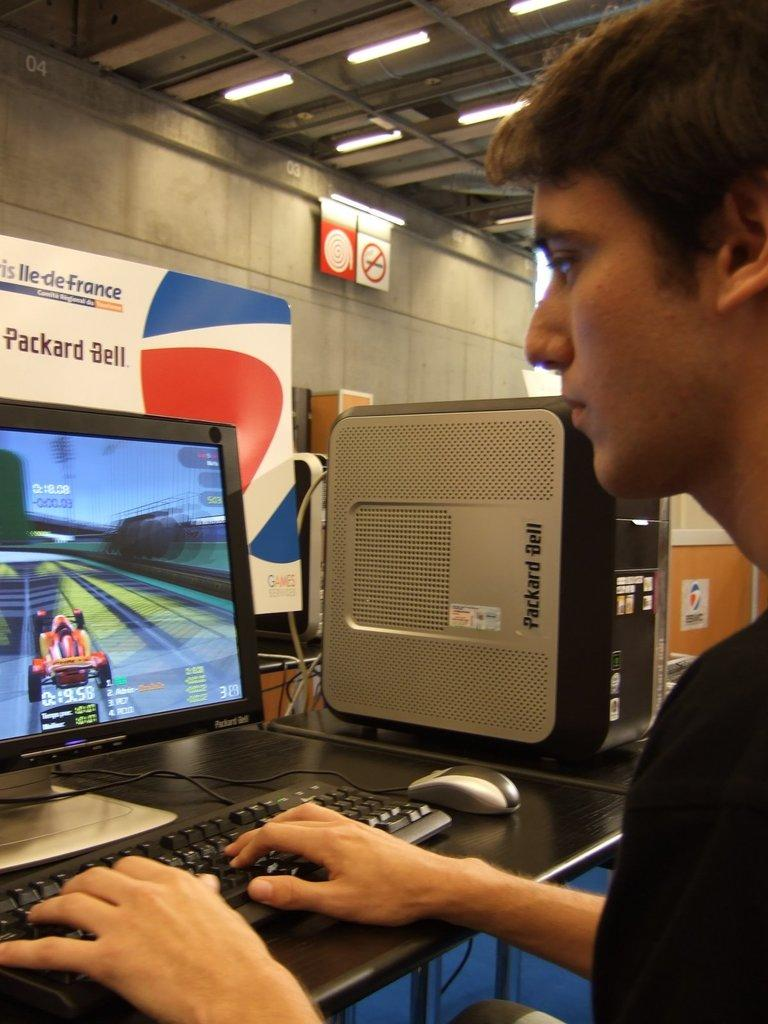<image>
Write a terse but informative summary of the picture. A man sitting in front of a Packard Bell computer and signe 